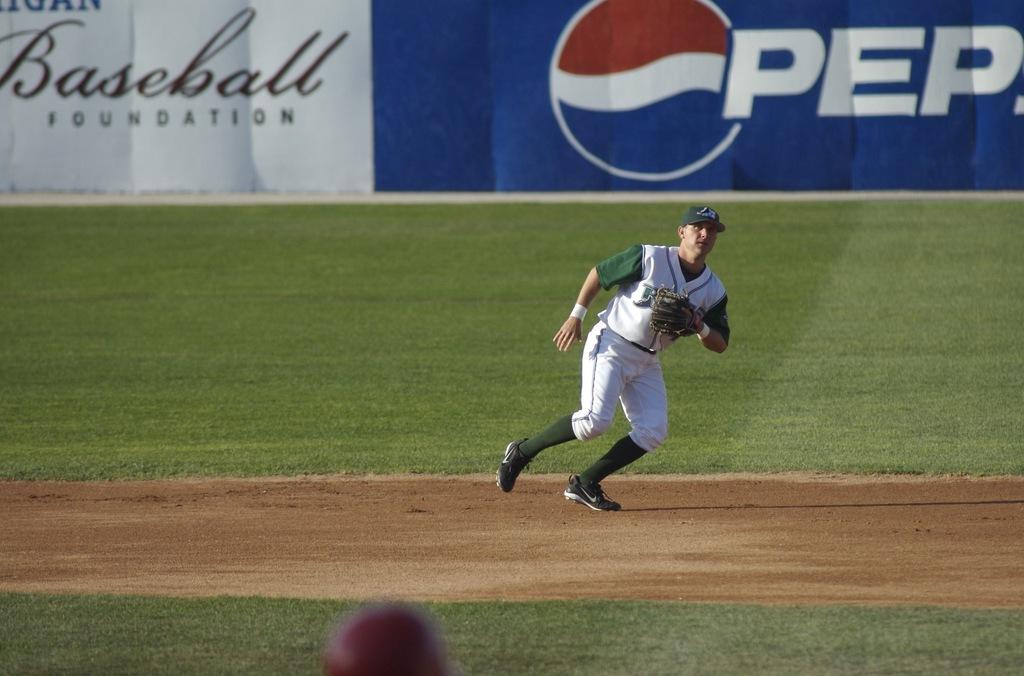What foundation is it?
Provide a short and direct response. Baseball. What is a sponsor of this ball field?
Offer a terse response. Pepsi. 